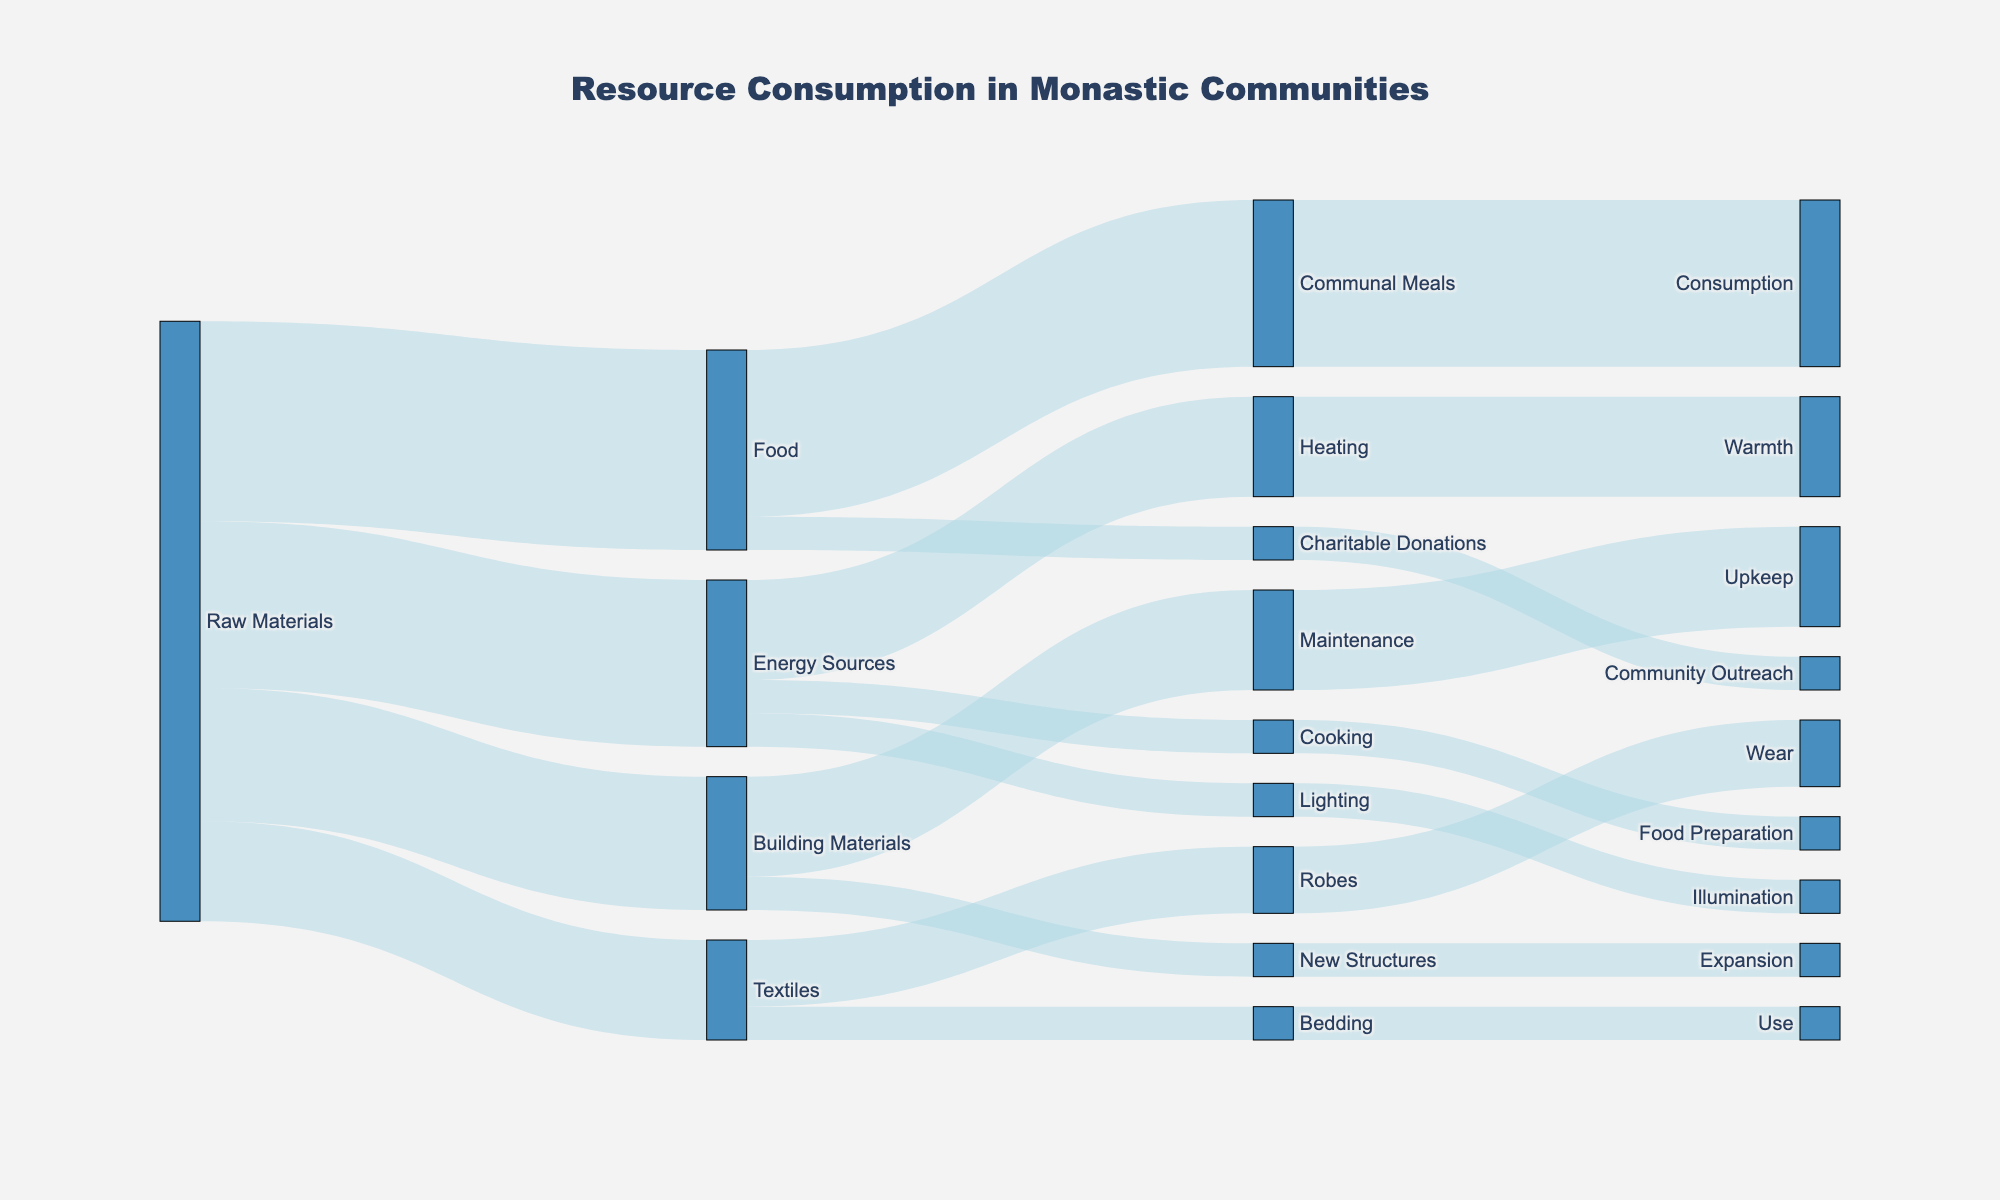What is the title of the Sankey diagram? The title is displayed at the top of the figure.
Answer: Resource Consumption in Monastic Communities Which resource has the highest initial consumption value? Check the values originating from 'Raw Materials' and compare them. The highest value is linked to 'Food' with a value of 30.
Answer: Food What are the end uses of 'Textiles'? Follow the paths from 'Textiles' to final nodes, which are 'Robes' and 'Bedding'.
Answer: Robes and Bedding How much of the 'Raw Materials' are allocated to 'Energy Sources'? Locate the path from 'Raw Materials' to 'Energy Sources' and read the associated value.
Answer: 25 What is the combined value of 'Maintenance' and 'New Structures'? Add the values for 'Maintenance' (15) and 'New Structures' (5). 15 + 5 = 20
Answer: 20 What uses more resources, 'Heating' or 'Lighting'? Compare the values for 'Heating' (15) and 'Lighting' (5). 'Heating' has a higher value.
Answer: Heating How much of the 'Raw Materials' are ultimately used for 'Food Preparation'? Trace the path from 'Raw Materials' to 'Energy Sources' to 'Cooking' to 'Food Preparation'. The value is 5.
Answer: 5 What is the total value of resources consumed by 'Communal Meals' and 'Charitable Donations'? Add the values for 'Communal Meals' (25) and 'Charitable Donations' (5). 25 + 5 = 30
Answer: 30 Which end use receives the least amount of resources? Compare all end nodes and find the smallest value, which is 'Illumination' with a value of 5.
Answer: Illumination How much 'Raw Materials' are allocated for 'Building Materials'? Locate the value from 'Raw Materials' to 'Building Materials'.
Answer: 20 